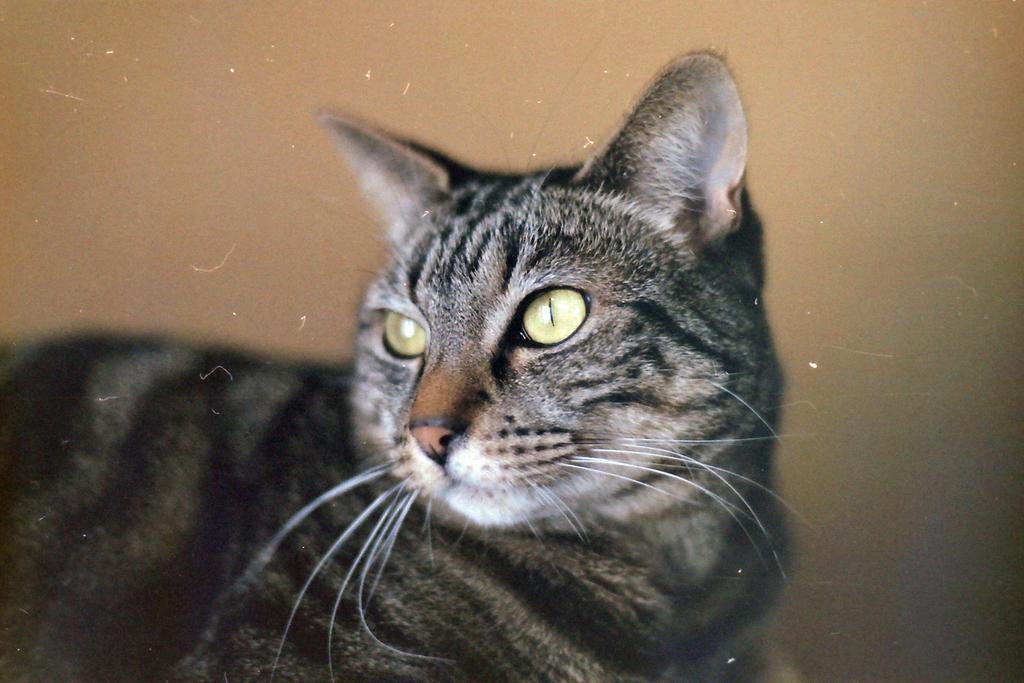Please provide a concise description of this image. In this image in the foreground there is a cat and in the background there is a wall. 